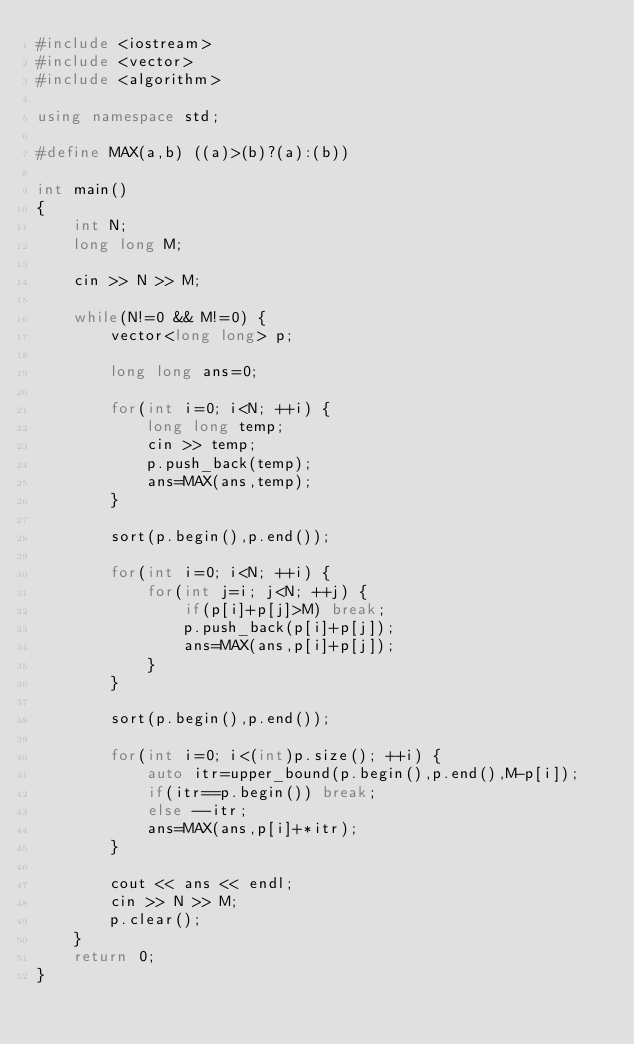Convert code to text. <code><loc_0><loc_0><loc_500><loc_500><_C++_>#include <iostream>
#include <vector>
#include <algorithm>

using namespace std;

#define MAX(a,b) ((a)>(b)?(a):(b))

int main()
{
    int N;
    long long M;

    cin >> N >> M;

    while(N!=0 && M!=0) {
        vector<long long> p;

        long long ans=0;

        for(int i=0; i<N; ++i) {
            long long temp;
            cin >> temp;
            p.push_back(temp);
            ans=MAX(ans,temp);
        }

        sort(p.begin(),p.end());

        for(int i=0; i<N; ++i) {
            for(int j=i; j<N; ++j) {
                if(p[i]+p[j]>M) break;
                p.push_back(p[i]+p[j]);
                ans=MAX(ans,p[i]+p[j]);
            }
        }

        sort(p.begin(),p.end());

        for(int i=0; i<(int)p.size(); ++i) {
            auto itr=upper_bound(p.begin(),p.end(),M-p[i]);
            if(itr==p.begin()) break;
            else --itr;
            ans=MAX(ans,p[i]+*itr);
        }

        cout << ans << endl;
        cin >> N >> M;
        p.clear();
    }
    return 0;
}</code> 